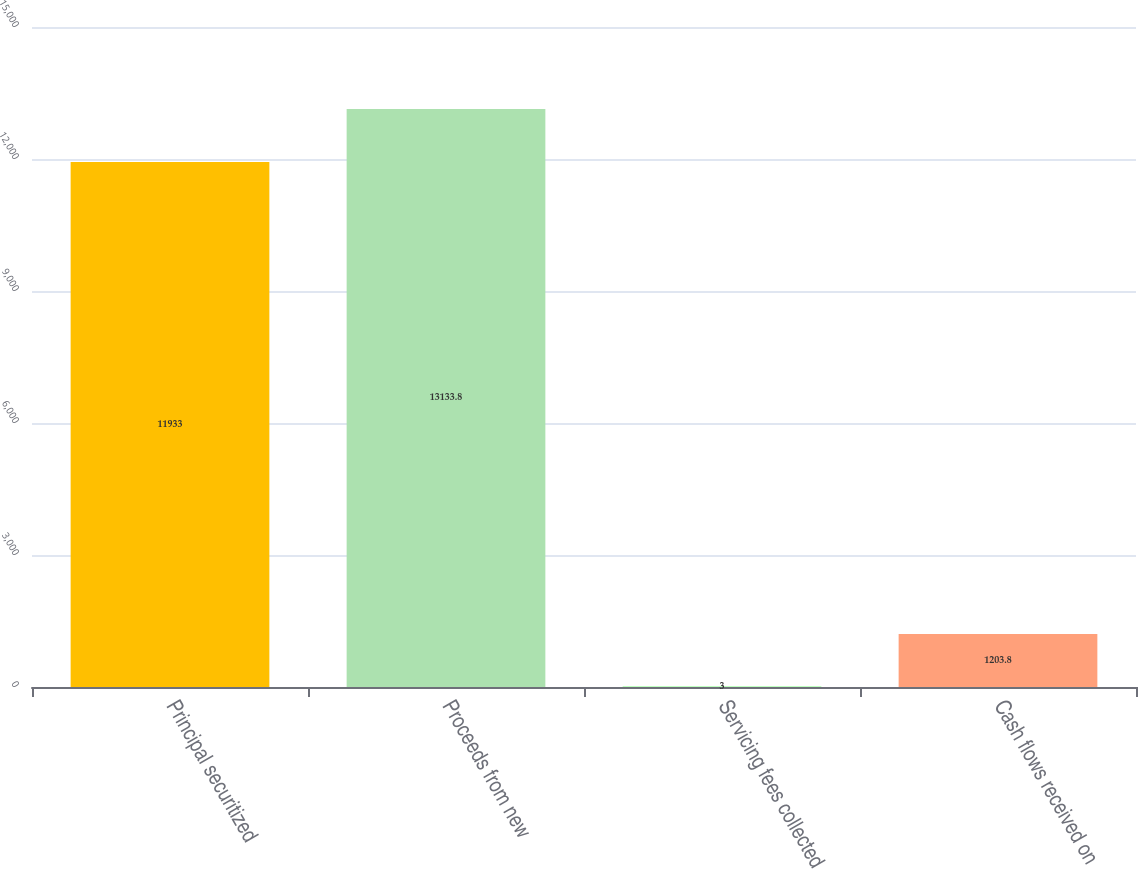<chart> <loc_0><loc_0><loc_500><loc_500><bar_chart><fcel>Principal securitized<fcel>Proceeds from new<fcel>Servicing fees collected<fcel>Cash flows received on<nl><fcel>11933<fcel>13133.8<fcel>3<fcel>1203.8<nl></chart> 